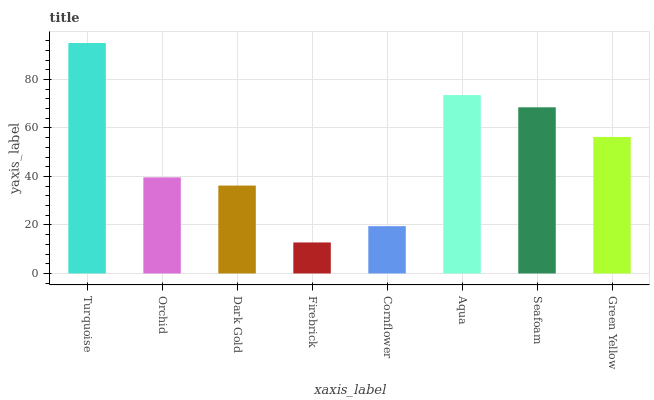Is Firebrick the minimum?
Answer yes or no. Yes. Is Turquoise the maximum?
Answer yes or no. Yes. Is Orchid the minimum?
Answer yes or no. No. Is Orchid the maximum?
Answer yes or no. No. Is Turquoise greater than Orchid?
Answer yes or no. Yes. Is Orchid less than Turquoise?
Answer yes or no. Yes. Is Orchid greater than Turquoise?
Answer yes or no. No. Is Turquoise less than Orchid?
Answer yes or no. No. Is Green Yellow the high median?
Answer yes or no. Yes. Is Orchid the low median?
Answer yes or no. Yes. Is Turquoise the high median?
Answer yes or no. No. Is Aqua the low median?
Answer yes or no. No. 